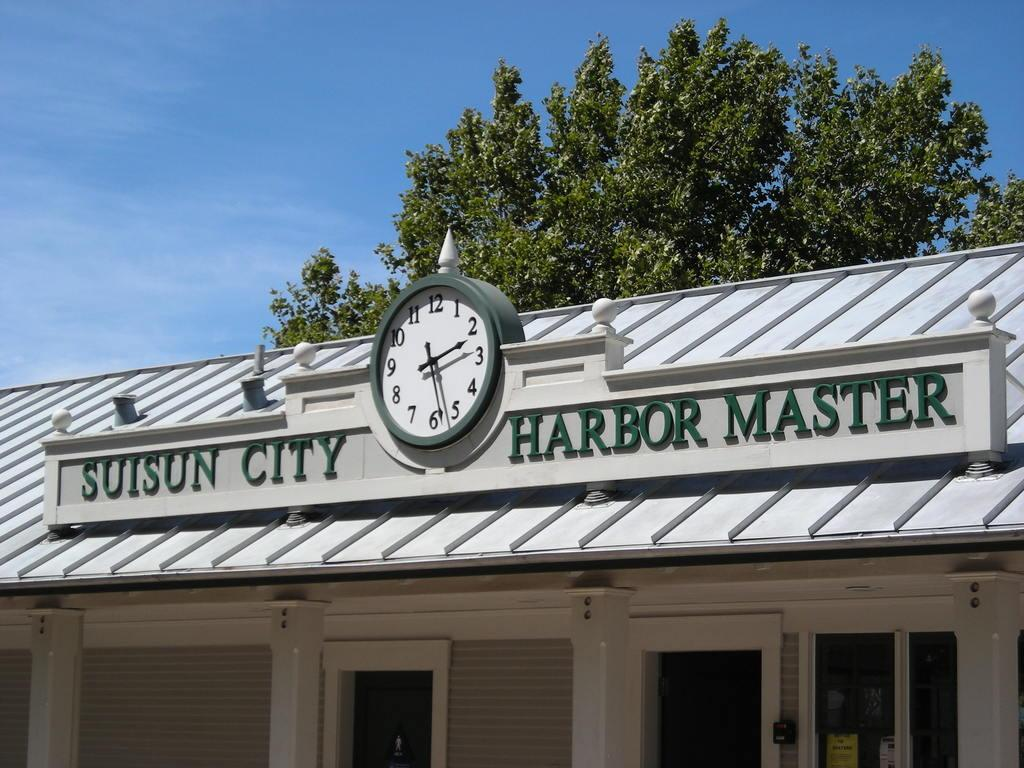<image>
Create a compact narrative representing the image presented. A building is called the Suisun City Harbor Master. 